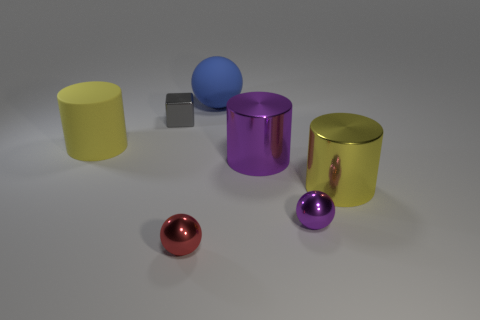Add 2 purple metallic balls. How many objects exist? 9 Subtract all cylinders. How many objects are left? 4 Add 4 small red spheres. How many small red spheres are left? 5 Add 5 tiny metal spheres. How many tiny metal spheres exist? 7 Subtract 1 red spheres. How many objects are left? 6 Subtract all large purple metal cylinders. Subtract all metallic things. How many objects are left? 1 